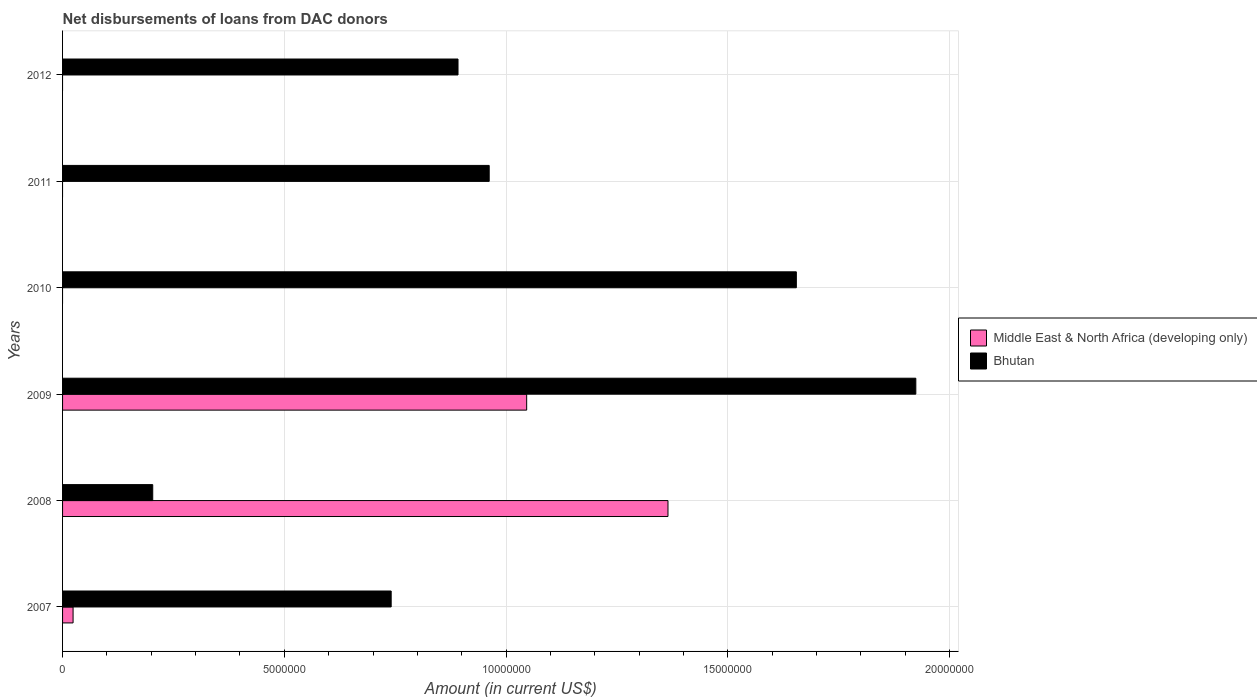How many different coloured bars are there?
Offer a terse response. 2. Are the number of bars on each tick of the Y-axis equal?
Give a very brief answer. No. What is the label of the 5th group of bars from the top?
Keep it short and to the point. 2008. In how many cases, is the number of bars for a given year not equal to the number of legend labels?
Offer a very short reply. 3. What is the amount of loans disbursed in Middle East & North Africa (developing only) in 2007?
Give a very brief answer. 2.37e+05. Across all years, what is the maximum amount of loans disbursed in Bhutan?
Ensure brevity in your answer.  1.92e+07. In which year was the amount of loans disbursed in Bhutan maximum?
Provide a succinct answer. 2009. What is the total amount of loans disbursed in Middle East & North Africa (developing only) in the graph?
Give a very brief answer. 2.44e+07. What is the difference between the amount of loans disbursed in Bhutan in 2009 and that in 2010?
Offer a terse response. 2.69e+06. What is the difference between the amount of loans disbursed in Middle East & North Africa (developing only) in 2010 and the amount of loans disbursed in Bhutan in 2012?
Offer a terse response. -8.92e+06. What is the average amount of loans disbursed in Bhutan per year?
Your answer should be very brief. 1.06e+07. In the year 2007, what is the difference between the amount of loans disbursed in Bhutan and amount of loans disbursed in Middle East & North Africa (developing only)?
Provide a succinct answer. 7.17e+06. What is the ratio of the amount of loans disbursed in Middle East & North Africa (developing only) in 2008 to that in 2009?
Provide a short and direct response. 1.3. Is the amount of loans disbursed in Bhutan in 2007 less than that in 2009?
Provide a short and direct response. Yes. What is the difference between the highest and the second highest amount of loans disbursed in Bhutan?
Offer a very short reply. 2.69e+06. What is the difference between the highest and the lowest amount of loans disbursed in Middle East & North Africa (developing only)?
Keep it short and to the point. 1.36e+07. How many bars are there?
Your answer should be compact. 9. How many years are there in the graph?
Make the answer very short. 6. What is the difference between two consecutive major ticks on the X-axis?
Offer a terse response. 5.00e+06. Does the graph contain grids?
Keep it short and to the point. Yes. Where does the legend appear in the graph?
Your answer should be very brief. Center right. What is the title of the graph?
Make the answer very short. Net disbursements of loans from DAC donors. Does "Middle East & North Africa (all income levels)" appear as one of the legend labels in the graph?
Ensure brevity in your answer.  No. What is the label or title of the Y-axis?
Provide a short and direct response. Years. What is the Amount (in current US$) in Middle East & North Africa (developing only) in 2007?
Provide a succinct answer. 2.37e+05. What is the Amount (in current US$) of Bhutan in 2007?
Your answer should be compact. 7.41e+06. What is the Amount (in current US$) of Middle East & North Africa (developing only) in 2008?
Ensure brevity in your answer.  1.36e+07. What is the Amount (in current US$) in Bhutan in 2008?
Provide a succinct answer. 2.03e+06. What is the Amount (in current US$) of Middle East & North Africa (developing only) in 2009?
Offer a very short reply. 1.05e+07. What is the Amount (in current US$) of Bhutan in 2009?
Offer a very short reply. 1.92e+07. What is the Amount (in current US$) of Middle East & North Africa (developing only) in 2010?
Offer a terse response. 0. What is the Amount (in current US$) of Bhutan in 2010?
Ensure brevity in your answer.  1.65e+07. What is the Amount (in current US$) of Middle East & North Africa (developing only) in 2011?
Ensure brevity in your answer.  0. What is the Amount (in current US$) in Bhutan in 2011?
Your response must be concise. 9.62e+06. What is the Amount (in current US$) of Bhutan in 2012?
Your answer should be very brief. 8.92e+06. Across all years, what is the maximum Amount (in current US$) in Middle East & North Africa (developing only)?
Provide a short and direct response. 1.36e+07. Across all years, what is the maximum Amount (in current US$) of Bhutan?
Make the answer very short. 1.92e+07. Across all years, what is the minimum Amount (in current US$) of Middle East & North Africa (developing only)?
Your answer should be very brief. 0. Across all years, what is the minimum Amount (in current US$) in Bhutan?
Provide a succinct answer. 2.03e+06. What is the total Amount (in current US$) of Middle East & North Africa (developing only) in the graph?
Keep it short and to the point. 2.44e+07. What is the total Amount (in current US$) of Bhutan in the graph?
Provide a succinct answer. 6.38e+07. What is the difference between the Amount (in current US$) of Middle East & North Africa (developing only) in 2007 and that in 2008?
Your response must be concise. -1.34e+07. What is the difference between the Amount (in current US$) of Bhutan in 2007 and that in 2008?
Provide a short and direct response. 5.38e+06. What is the difference between the Amount (in current US$) of Middle East & North Africa (developing only) in 2007 and that in 2009?
Your response must be concise. -1.02e+07. What is the difference between the Amount (in current US$) of Bhutan in 2007 and that in 2009?
Offer a terse response. -1.18e+07. What is the difference between the Amount (in current US$) in Bhutan in 2007 and that in 2010?
Make the answer very short. -9.14e+06. What is the difference between the Amount (in current US$) in Bhutan in 2007 and that in 2011?
Offer a very short reply. -2.21e+06. What is the difference between the Amount (in current US$) in Bhutan in 2007 and that in 2012?
Offer a very short reply. -1.51e+06. What is the difference between the Amount (in current US$) in Middle East & North Africa (developing only) in 2008 and that in 2009?
Your answer should be very brief. 3.19e+06. What is the difference between the Amount (in current US$) in Bhutan in 2008 and that in 2009?
Ensure brevity in your answer.  -1.72e+07. What is the difference between the Amount (in current US$) in Bhutan in 2008 and that in 2010?
Make the answer very short. -1.45e+07. What is the difference between the Amount (in current US$) in Bhutan in 2008 and that in 2011?
Make the answer very short. -7.59e+06. What is the difference between the Amount (in current US$) of Bhutan in 2008 and that in 2012?
Give a very brief answer. -6.88e+06. What is the difference between the Amount (in current US$) of Bhutan in 2009 and that in 2010?
Your answer should be compact. 2.69e+06. What is the difference between the Amount (in current US$) of Bhutan in 2009 and that in 2011?
Give a very brief answer. 9.62e+06. What is the difference between the Amount (in current US$) in Bhutan in 2009 and that in 2012?
Ensure brevity in your answer.  1.03e+07. What is the difference between the Amount (in current US$) of Bhutan in 2010 and that in 2011?
Ensure brevity in your answer.  6.92e+06. What is the difference between the Amount (in current US$) in Bhutan in 2010 and that in 2012?
Your answer should be very brief. 7.63e+06. What is the difference between the Amount (in current US$) of Bhutan in 2011 and that in 2012?
Your answer should be compact. 7.03e+05. What is the difference between the Amount (in current US$) in Middle East & North Africa (developing only) in 2007 and the Amount (in current US$) in Bhutan in 2008?
Keep it short and to the point. -1.80e+06. What is the difference between the Amount (in current US$) of Middle East & North Africa (developing only) in 2007 and the Amount (in current US$) of Bhutan in 2009?
Your response must be concise. -1.90e+07. What is the difference between the Amount (in current US$) in Middle East & North Africa (developing only) in 2007 and the Amount (in current US$) in Bhutan in 2010?
Provide a succinct answer. -1.63e+07. What is the difference between the Amount (in current US$) in Middle East & North Africa (developing only) in 2007 and the Amount (in current US$) in Bhutan in 2011?
Keep it short and to the point. -9.38e+06. What is the difference between the Amount (in current US$) of Middle East & North Africa (developing only) in 2007 and the Amount (in current US$) of Bhutan in 2012?
Your answer should be compact. -8.68e+06. What is the difference between the Amount (in current US$) of Middle East & North Africa (developing only) in 2008 and the Amount (in current US$) of Bhutan in 2009?
Keep it short and to the point. -5.59e+06. What is the difference between the Amount (in current US$) in Middle East & North Africa (developing only) in 2008 and the Amount (in current US$) in Bhutan in 2010?
Your answer should be compact. -2.89e+06. What is the difference between the Amount (in current US$) of Middle East & North Africa (developing only) in 2008 and the Amount (in current US$) of Bhutan in 2011?
Your answer should be very brief. 4.03e+06. What is the difference between the Amount (in current US$) in Middle East & North Africa (developing only) in 2008 and the Amount (in current US$) in Bhutan in 2012?
Keep it short and to the point. 4.73e+06. What is the difference between the Amount (in current US$) in Middle East & North Africa (developing only) in 2009 and the Amount (in current US$) in Bhutan in 2010?
Provide a short and direct response. -6.08e+06. What is the difference between the Amount (in current US$) in Middle East & North Africa (developing only) in 2009 and the Amount (in current US$) in Bhutan in 2011?
Provide a succinct answer. 8.45e+05. What is the difference between the Amount (in current US$) of Middle East & North Africa (developing only) in 2009 and the Amount (in current US$) of Bhutan in 2012?
Your response must be concise. 1.55e+06. What is the average Amount (in current US$) in Middle East & North Africa (developing only) per year?
Ensure brevity in your answer.  4.06e+06. What is the average Amount (in current US$) in Bhutan per year?
Provide a succinct answer. 1.06e+07. In the year 2007, what is the difference between the Amount (in current US$) in Middle East & North Africa (developing only) and Amount (in current US$) in Bhutan?
Ensure brevity in your answer.  -7.17e+06. In the year 2008, what is the difference between the Amount (in current US$) in Middle East & North Africa (developing only) and Amount (in current US$) in Bhutan?
Provide a short and direct response. 1.16e+07. In the year 2009, what is the difference between the Amount (in current US$) in Middle East & North Africa (developing only) and Amount (in current US$) in Bhutan?
Offer a terse response. -8.77e+06. What is the ratio of the Amount (in current US$) of Middle East & North Africa (developing only) in 2007 to that in 2008?
Offer a very short reply. 0.02. What is the ratio of the Amount (in current US$) of Bhutan in 2007 to that in 2008?
Give a very brief answer. 3.64. What is the ratio of the Amount (in current US$) in Middle East & North Africa (developing only) in 2007 to that in 2009?
Your response must be concise. 0.02. What is the ratio of the Amount (in current US$) of Bhutan in 2007 to that in 2009?
Make the answer very short. 0.39. What is the ratio of the Amount (in current US$) in Bhutan in 2007 to that in 2010?
Offer a terse response. 0.45. What is the ratio of the Amount (in current US$) in Bhutan in 2007 to that in 2011?
Offer a very short reply. 0.77. What is the ratio of the Amount (in current US$) in Bhutan in 2007 to that in 2012?
Offer a very short reply. 0.83. What is the ratio of the Amount (in current US$) in Middle East & North Africa (developing only) in 2008 to that in 2009?
Offer a terse response. 1.3. What is the ratio of the Amount (in current US$) in Bhutan in 2008 to that in 2009?
Ensure brevity in your answer.  0.11. What is the ratio of the Amount (in current US$) of Bhutan in 2008 to that in 2010?
Provide a succinct answer. 0.12. What is the ratio of the Amount (in current US$) of Bhutan in 2008 to that in 2011?
Offer a terse response. 0.21. What is the ratio of the Amount (in current US$) of Bhutan in 2008 to that in 2012?
Offer a very short reply. 0.23. What is the ratio of the Amount (in current US$) of Bhutan in 2009 to that in 2010?
Make the answer very short. 1.16. What is the ratio of the Amount (in current US$) of Bhutan in 2009 to that in 2011?
Provide a succinct answer. 2. What is the ratio of the Amount (in current US$) of Bhutan in 2009 to that in 2012?
Your answer should be compact. 2.16. What is the ratio of the Amount (in current US$) in Bhutan in 2010 to that in 2011?
Ensure brevity in your answer.  1.72. What is the ratio of the Amount (in current US$) of Bhutan in 2010 to that in 2012?
Provide a succinct answer. 1.86. What is the ratio of the Amount (in current US$) of Bhutan in 2011 to that in 2012?
Give a very brief answer. 1.08. What is the difference between the highest and the second highest Amount (in current US$) of Middle East & North Africa (developing only)?
Offer a terse response. 3.19e+06. What is the difference between the highest and the second highest Amount (in current US$) of Bhutan?
Provide a succinct answer. 2.69e+06. What is the difference between the highest and the lowest Amount (in current US$) of Middle East & North Africa (developing only)?
Keep it short and to the point. 1.36e+07. What is the difference between the highest and the lowest Amount (in current US$) in Bhutan?
Make the answer very short. 1.72e+07. 